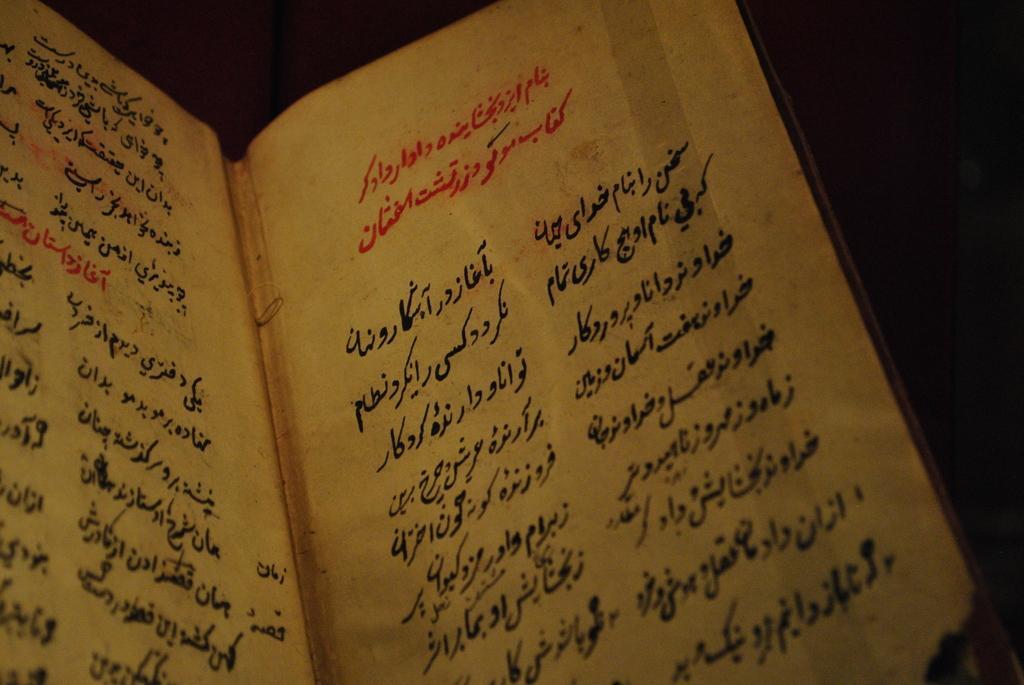What is the main subject in the image? There is an open book in the image. What can be seen on the open book? There is text visible on the open book. Can you see a ghost reading the open book in the image? There is no ghost present in the image. What type of tooth is visible in the image? There are no teeth present in the image. 